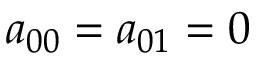<formula> <loc_0><loc_0><loc_500><loc_500>a _ { 0 0 } = a _ { 0 1 } = 0</formula> 